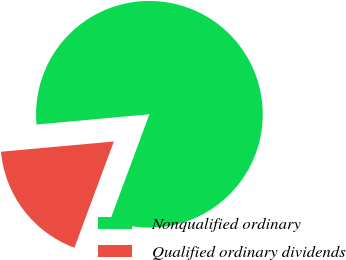Convert chart to OTSL. <chart><loc_0><loc_0><loc_500><loc_500><pie_chart><fcel>Nonqualified ordinary<fcel>Qualified ordinary dividends<nl><fcel>82.1%<fcel>17.9%<nl></chart> 